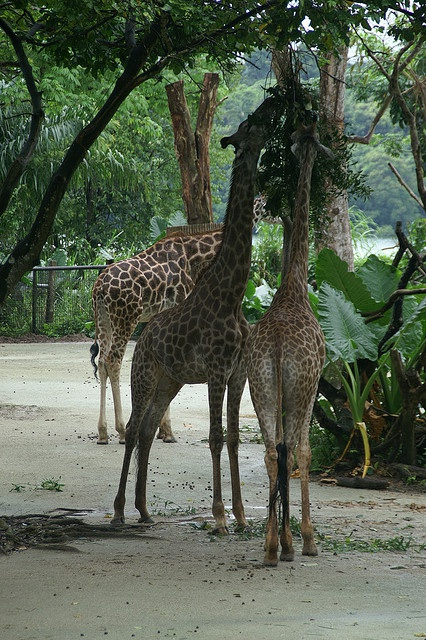Describe the objects in this image and their specific colors. I can see giraffe in black, darkgray, and gray tones, giraffe in black and gray tones, and giraffe in black, gray, darkgray, and darkgreen tones in this image. 